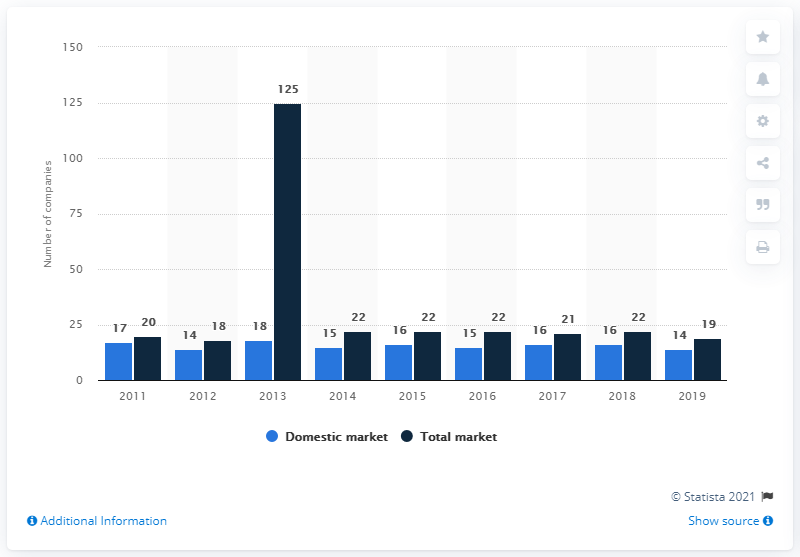Draw attention to some important aspects in this diagram. In 2019, there were 14 companies active on the Slovenian insurance market. In 2019, the domestic market and the total market had distinct differences. As of the end of 2019, a total of 19 companies were operating on the market in Slovenia. The market with the highest number of companies is the total market. 